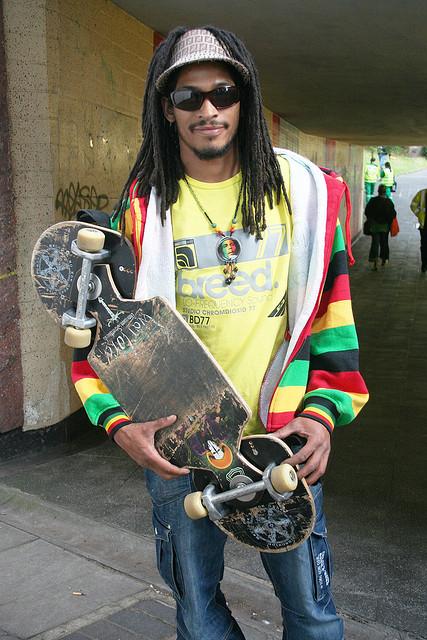Is the man wearing sunglasses?
Keep it brief. Yes. What type of hat is this man wearing?
Keep it brief. Fedora. What is this man's hairstyle called?
Write a very short answer. Dreadlocks. 